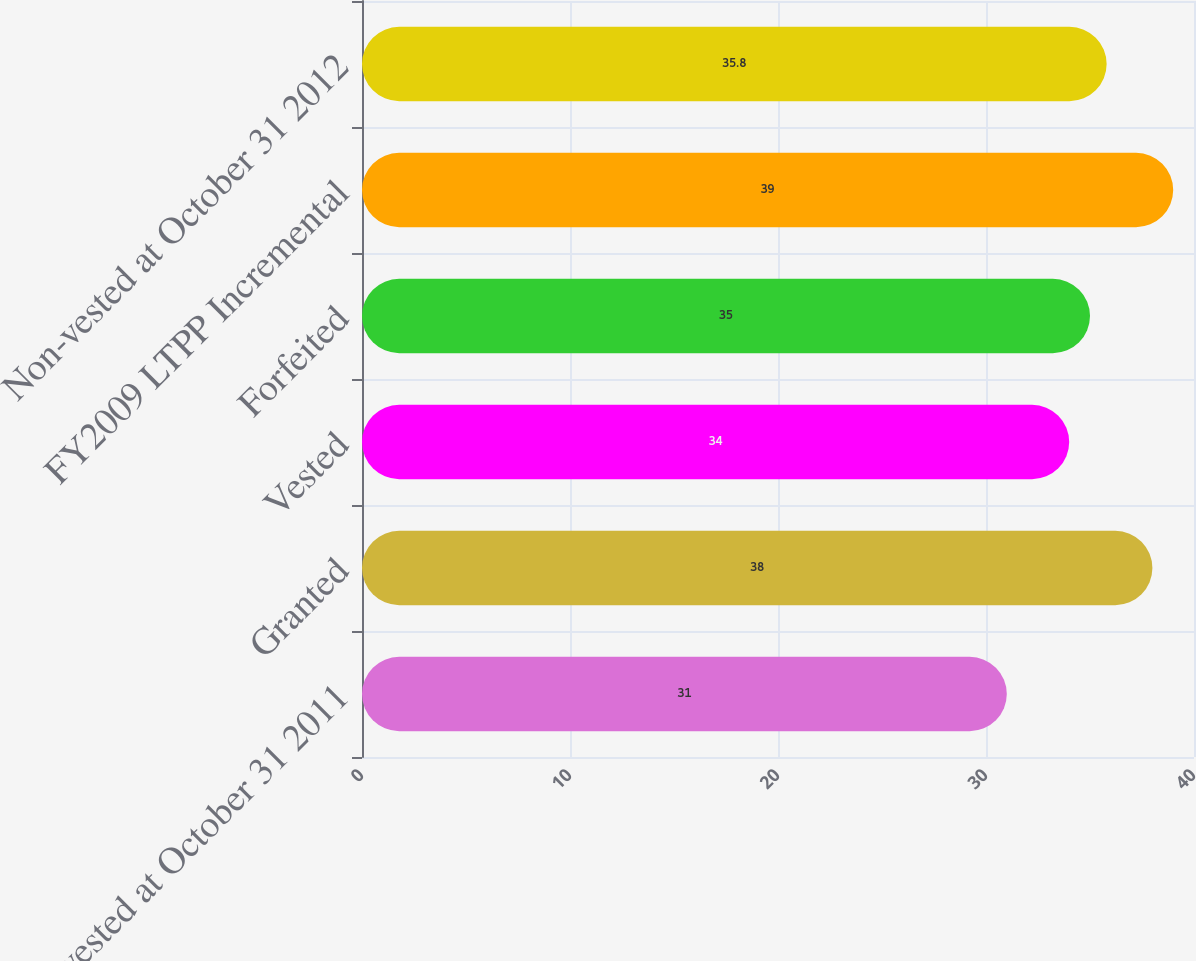Convert chart to OTSL. <chart><loc_0><loc_0><loc_500><loc_500><bar_chart><fcel>Non-vested at October 31 2011<fcel>Granted<fcel>Vested<fcel>Forfeited<fcel>FY2009 LTPP Incremental<fcel>Non-vested at October 31 2012<nl><fcel>31<fcel>38<fcel>34<fcel>35<fcel>39<fcel>35.8<nl></chart> 